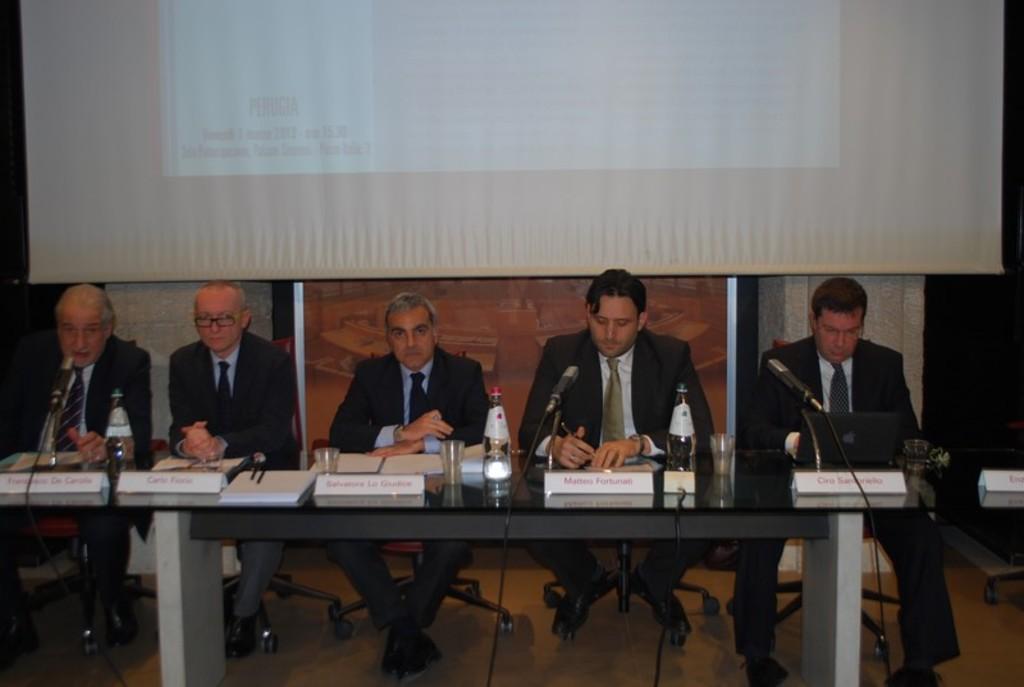In one or two sentences, can you explain what this image depicts? In this image we can see five persons sitting on the chairs near the table. There are mice, bottles, glasses and laptop on the table. In the background we can see a projector screen. 